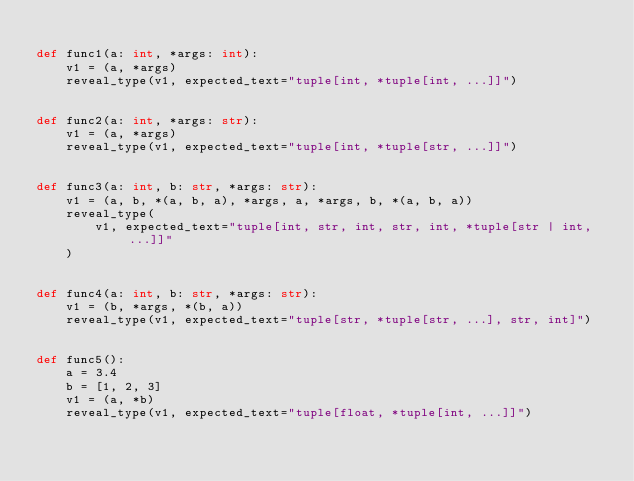<code> <loc_0><loc_0><loc_500><loc_500><_Python_>
def func1(a: int, *args: int):
    v1 = (a, *args)
    reveal_type(v1, expected_text="tuple[int, *tuple[int, ...]]")


def func2(a: int, *args: str):
    v1 = (a, *args)
    reveal_type(v1, expected_text="tuple[int, *tuple[str, ...]]")


def func3(a: int, b: str, *args: str):
    v1 = (a, b, *(a, b, a), *args, a, *args, b, *(a, b, a))
    reveal_type(
        v1, expected_text="tuple[int, str, int, str, int, *tuple[str | int, ...]]"
    )


def func4(a: int, b: str, *args: str):
    v1 = (b, *args, *(b, a))
    reveal_type(v1, expected_text="tuple[str, *tuple[str, ...], str, int]")


def func5():
    a = 3.4
    b = [1, 2, 3]
    v1 = (a, *b)
    reveal_type(v1, expected_text="tuple[float, *tuple[int, ...]]")
</code> 